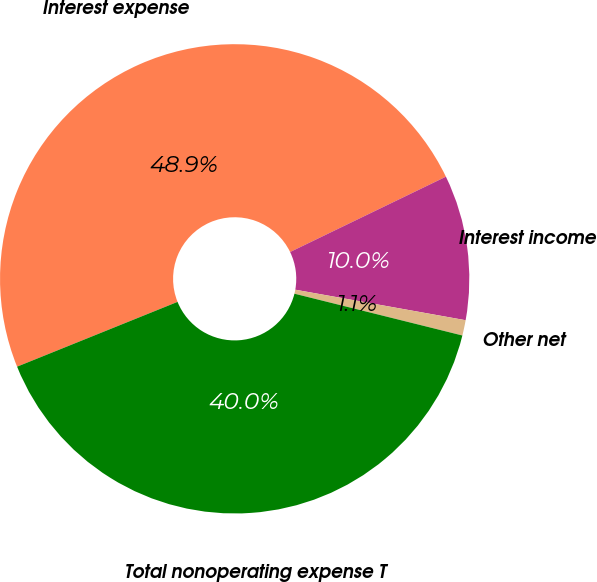<chart> <loc_0><loc_0><loc_500><loc_500><pie_chart><fcel>Interest expense<fcel>Interest income<fcel>Other net<fcel>Total nonoperating expense T<nl><fcel>48.94%<fcel>9.99%<fcel>1.06%<fcel>40.01%<nl></chart> 